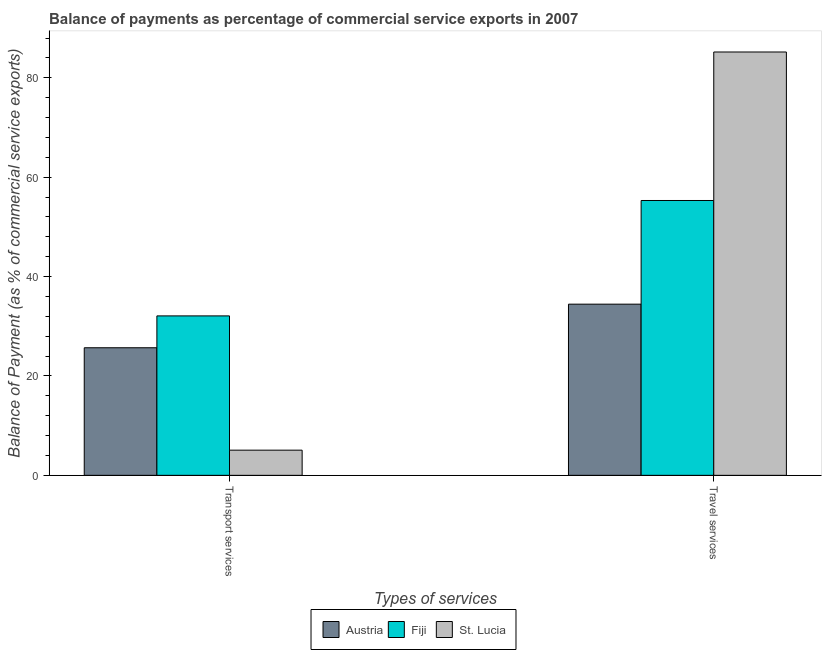How many different coloured bars are there?
Provide a succinct answer. 3. How many groups of bars are there?
Provide a succinct answer. 2. Are the number of bars per tick equal to the number of legend labels?
Give a very brief answer. Yes. Are the number of bars on each tick of the X-axis equal?
Keep it short and to the point. Yes. What is the label of the 2nd group of bars from the left?
Make the answer very short. Travel services. What is the balance of payments of travel services in St. Lucia?
Ensure brevity in your answer.  85.2. Across all countries, what is the maximum balance of payments of travel services?
Make the answer very short. 85.2. Across all countries, what is the minimum balance of payments of travel services?
Make the answer very short. 34.45. In which country was the balance of payments of travel services maximum?
Keep it short and to the point. St. Lucia. What is the total balance of payments of travel services in the graph?
Your answer should be compact. 174.96. What is the difference between the balance of payments of transport services in Fiji and that in St. Lucia?
Give a very brief answer. 27.02. What is the difference between the balance of payments of transport services in Austria and the balance of payments of travel services in Fiji?
Give a very brief answer. -29.64. What is the average balance of payments of travel services per country?
Make the answer very short. 58.32. What is the difference between the balance of payments of transport services and balance of payments of travel services in St. Lucia?
Ensure brevity in your answer.  -80.13. In how many countries, is the balance of payments of travel services greater than 24 %?
Offer a terse response. 3. What is the ratio of the balance of payments of transport services in Austria to that in Fiji?
Ensure brevity in your answer.  0.8. What does the 3rd bar from the left in Transport services represents?
Offer a very short reply. St. Lucia. What does the 1st bar from the right in Transport services represents?
Your answer should be very brief. St. Lucia. How many bars are there?
Offer a very short reply. 6. Are the values on the major ticks of Y-axis written in scientific E-notation?
Your response must be concise. No. Does the graph contain any zero values?
Make the answer very short. No. Does the graph contain grids?
Your response must be concise. No. Where does the legend appear in the graph?
Your response must be concise. Bottom center. How are the legend labels stacked?
Make the answer very short. Horizontal. What is the title of the graph?
Offer a terse response. Balance of payments as percentage of commercial service exports in 2007. Does "Uganda" appear as one of the legend labels in the graph?
Provide a succinct answer. No. What is the label or title of the X-axis?
Offer a very short reply. Types of services. What is the label or title of the Y-axis?
Keep it short and to the point. Balance of Payment (as % of commercial service exports). What is the Balance of Payment (as % of commercial service exports) in Austria in Transport services?
Keep it short and to the point. 25.68. What is the Balance of Payment (as % of commercial service exports) of Fiji in Transport services?
Your answer should be very brief. 32.09. What is the Balance of Payment (as % of commercial service exports) of St. Lucia in Transport services?
Your answer should be compact. 5.07. What is the Balance of Payment (as % of commercial service exports) of Austria in Travel services?
Your response must be concise. 34.45. What is the Balance of Payment (as % of commercial service exports) of Fiji in Travel services?
Give a very brief answer. 55.31. What is the Balance of Payment (as % of commercial service exports) in St. Lucia in Travel services?
Provide a short and direct response. 85.2. Across all Types of services, what is the maximum Balance of Payment (as % of commercial service exports) in Austria?
Offer a very short reply. 34.45. Across all Types of services, what is the maximum Balance of Payment (as % of commercial service exports) in Fiji?
Provide a succinct answer. 55.31. Across all Types of services, what is the maximum Balance of Payment (as % of commercial service exports) in St. Lucia?
Give a very brief answer. 85.2. Across all Types of services, what is the minimum Balance of Payment (as % of commercial service exports) of Austria?
Make the answer very short. 25.68. Across all Types of services, what is the minimum Balance of Payment (as % of commercial service exports) in Fiji?
Your response must be concise. 32.09. Across all Types of services, what is the minimum Balance of Payment (as % of commercial service exports) in St. Lucia?
Your answer should be compact. 5.07. What is the total Balance of Payment (as % of commercial service exports) in Austria in the graph?
Offer a very short reply. 60.12. What is the total Balance of Payment (as % of commercial service exports) in Fiji in the graph?
Offer a terse response. 87.4. What is the total Balance of Payment (as % of commercial service exports) of St. Lucia in the graph?
Your answer should be very brief. 90.27. What is the difference between the Balance of Payment (as % of commercial service exports) of Austria in Transport services and that in Travel services?
Ensure brevity in your answer.  -8.77. What is the difference between the Balance of Payment (as % of commercial service exports) of Fiji in Transport services and that in Travel services?
Your answer should be very brief. -23.22. What is the difference between the Balance of Payment (as % of commercial service exports) in St. Lucia in Transport services and that in Travel services?
Offer a very short reply. -80.13. What is the difference between the Balance of Payment (as % of commercial service exports) in Austria in Transport services and the Balance of Payment (as % of commercial service exports) in Fiji in Travel services?
Offer a very short reply. -29.64. What is the difference between the Balance of Payment (as % of commercial service exports) in Austria in Transport services and the Balance of Payment (as % of commercial service exports) in St. Lucia in Travel services?
Offer a terse response. -59.52. What is the difference between the Balance of Payment (as % of commercial service exports) of Fiji in Transport services and the Balance of Payment (as % of commercial service exports) of St. Lucia in Travel services?
Make the answer very short. -53.11. What is the average Balance of Payment (as % of commercial service exports) of Austria per Types of services?
Make the answer very short. 30.06. What is the average Balance of Payment (as % of commercial service exports) in Fiji per Types of services?
Provide a succinct answer. 43.7. What is the average Balance of Payment (as % of commercial service exports) of St. Lucia per Types of services?
Provide a succinct answer. 45.13. What is the difference between the Balance of Payment (as % of commercial service exports) of Austria and Balance of Payment (as % of commercial service exports) of Fiji in Transport services?
Give a very brief answer. -6.41. What is the difference between the Balance of Payment (as % of commercial service exports) in Austria and Balance of Payment (as % of commercial service exports) in St. Lucia in Transport services?
Provide a short and direct response. 20.61. What is the difference between the Balance of Payment (as % of commercial service exports) in Fiji and Balance of Payment (as % of commercial service exports) in St. Lucia in Transport services?
Your answer should be very brief. 27.02. What is the difference between the Balance of Payment (as % of commercial service exports) of Austria and Balance of Payment (as % of commercial service exports) of Fiji in Travel services?
Provide a succinct answer. -20.86. What is the difference between the Balance of Payment (as % of commercial service exports) in Austria and Balance of Payment (as % of commercial service exports) in St. Lucia in Travel services?
Ensure brevity in your answer.  -50.75. What is the difference between the Balance of Payment (as % of commercial service exports) of Fiji and Balance of Payment (as % of commercial service exports) of St. Lucia in Travel services?
Give a very brief answer. -29.89. What is the ratio of the Balance of Payment (as % of commercial service exports) in Austria in Transport services to that in Travel services?
Your answer should be compact. 0.75. What is the ratio of the Balance of Payment (as % of commercial service exports) of Fiji in Transport services to that in Travel services?
Your response must be concise. 0.58. What is the ratio of the Balance of Payment (as % of commercial service exports) of St. Lucia in Transport services to that in Travel services?
Your answer should be very brief. 0.06. What is the difference between the highest and the second highest Balance of Payment (as % of commercial service exports) in Austria?
Give a very brief answer. 8.77. What is the difference between the highest and the second highest Balance of Payment (as % of commercial service exports) in Fiji?
Give a very brief answer. 23.22. What is the difference between the highest and the second highest Balance of Payment (as % of commercial service exports) in St. Lucia?
Your answer should be very brief. 80.13. What is the difference between the highest and the lowest Balance of Payment (as % of commercial service exports) of Austria?
Offer a very short reply. 8.77. What is the difference between the highest and the lowest Balance of Payment (as % of commercial service exports) in Fiji?
Keep it short and to the point. 23.22. What is the difference between the highest and the lowest Balance of Payment (as % of commercial service exports) in St. Lucia?
Provide a short and direct response. 80.13. 